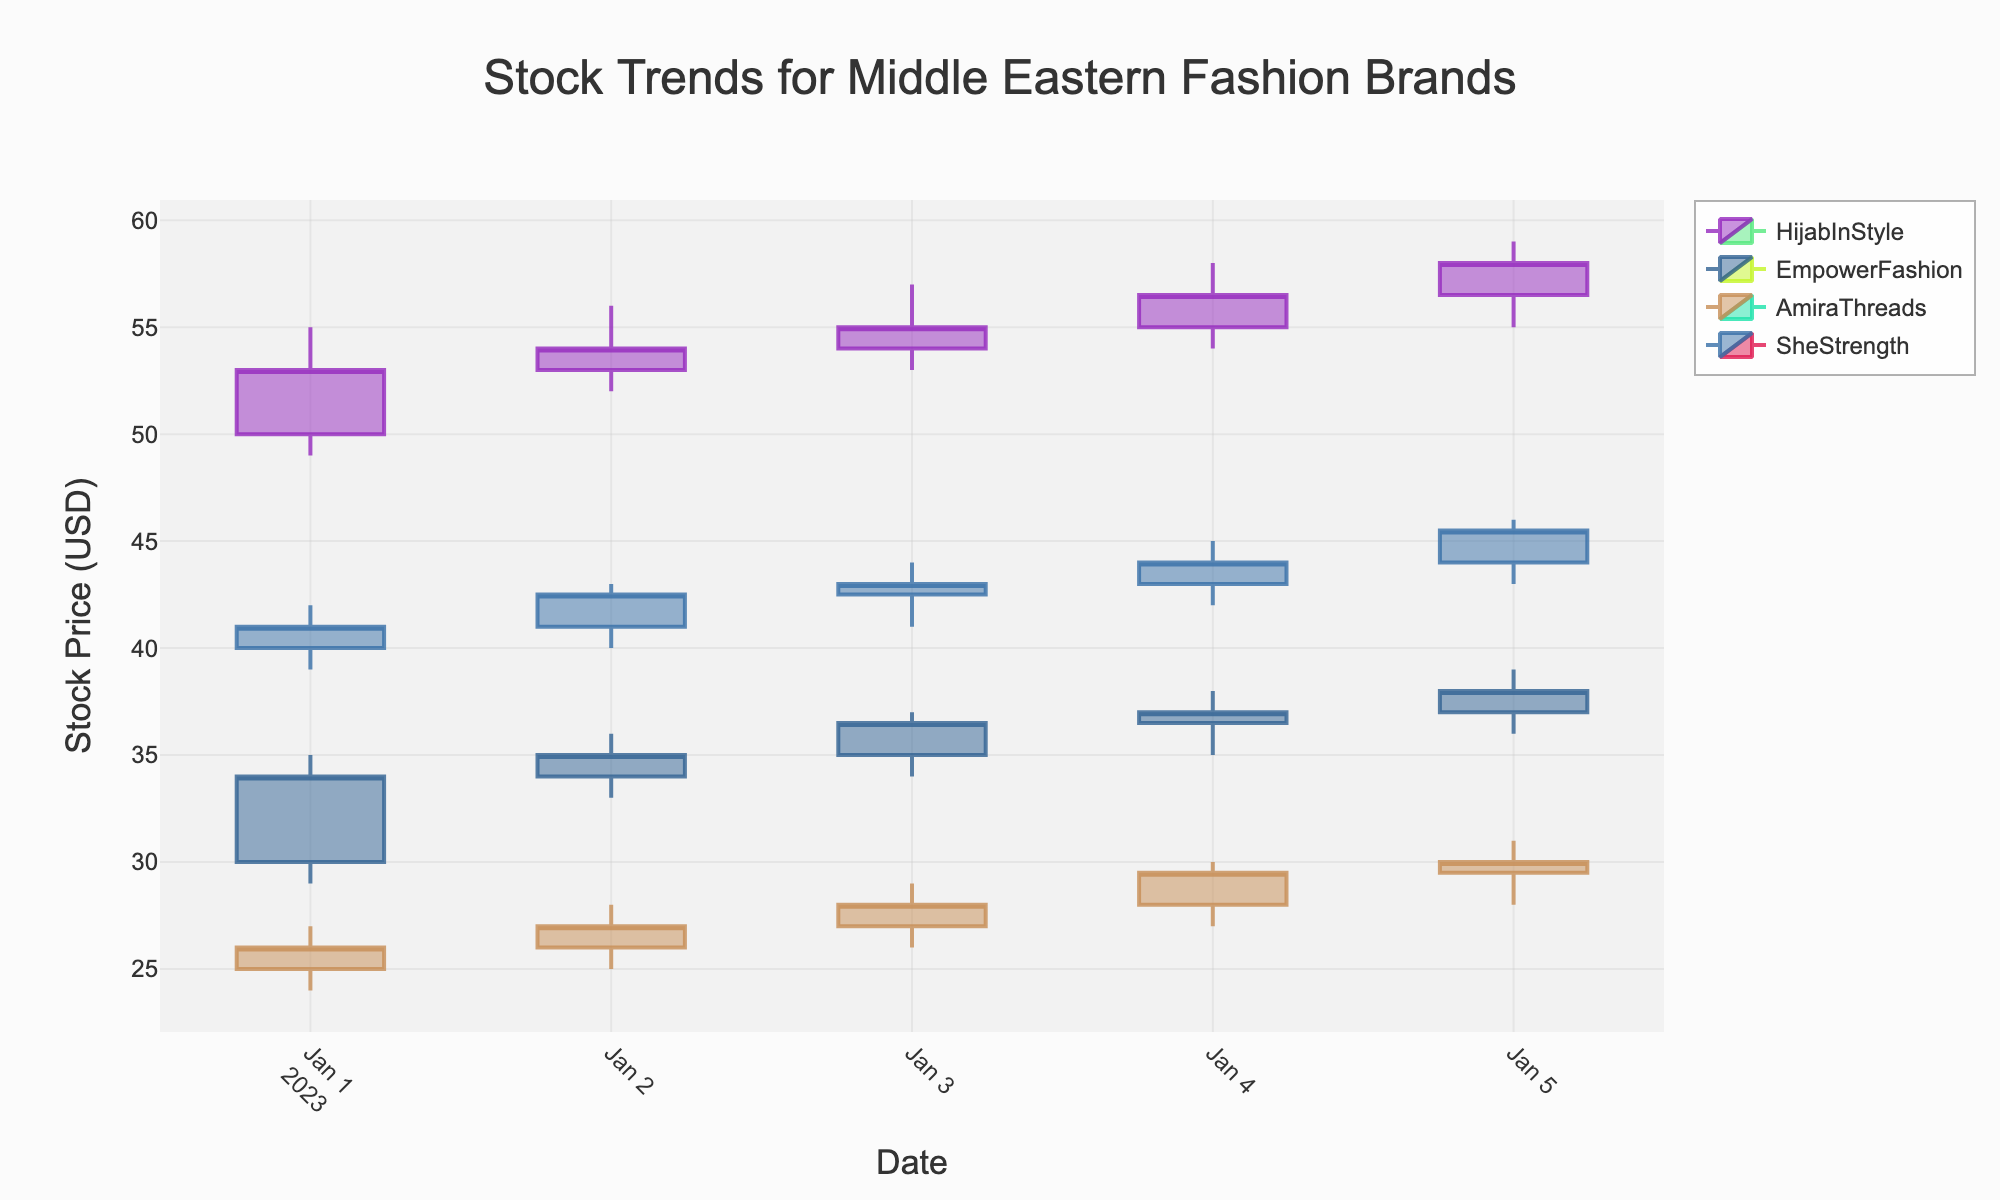Which brand has the highest closing price on January 5th? By observing the closing prices on January 5th, we compare HijabInStyle (58.0), EmpowerFashion (38.0), AmiraThreads (30.0), and SheStrength (45.5). HijabInStyle has the highest closing price.
Answer: HijabInStyle What is the average opening price for EmpwerFashion from January 1st to January 5th? The opening prices for EmpowerFashion from January 1st to January 5th are 30.0, 34.0, 35.0, 36.5, 37.0. The sum of these prices is 30.0 + 34.0 + 35.0 + 36.5 + 37.0, which equals 172.5. Dividing by 5 trading days, the average is 34.5.
Answer: 34.5 Which brand exhibited the largest increase in stock price over the period? To determine the largest increase, we calculate the difference between the closing prices on January 5th and January 1st for each brand. HijabInStyle increased from 53.0 to 58.0 (+5.0), EmpowerFashion from 34.0 to 38.0 (+4.0), AmiraThreads from 26.0 to 30.0 (+4.0), and SheStrength from 41.0 to 45.5 (+4.5). HijabInStyle shows the largest increase.
Answer: HijabInStyle Between AmiraThreads and SheStrength, which brand had a larger volume traded on January 3rd? On January 3rd, the volume traded for AmiraThreads is 1200 and for SheStrength is 1500. Comparing these values, SheStrength had the larger volume traded.
Answer: SheStrength On which date did HijabInStyle experience the highest single-day price increase in terms of closing price? Checking the daily differences in closing prices for HijabInStyle, we find: Jan 2: +1.0, Jan 3: +1.0, Jan 4: +1.5, Jan 5: +1.5. The highest single-day increase of +1.5 happened on January 4th and January 5th.
Answer: January 4th and 5th What is the total volume traded for HijabInStyle from January 1st to January 5th? The total volume is the sum of daily volumes for HijabInStyle from January 1st to January 5th: 1500 + 1600 + 1700 + 1800 + 1900 = 8500.
Answer: 8500 How does the closing price of EmpowerFashion on January 3rd compare to the opening price on the same day? The opening price for EmpowerFashion on January 3rd is 35.0 and the closing price is 36.5. Hence, the closing price is higher by 1.5.
Answer: Higher by 1.5 Which brand's stock price was the most stable, considering the smallest range (difference between high and low prices) over the period? To find stability, calculate the range (high - low) for each day, then average them for the period. HijabInStyle: avg(6)+avg(4)=Avg(5), EmpowerFashion=Avg(4.5), AmiraThreads=Avg(4), SheStrength=Avg(3.5)= SheStrength has the smallest ranges.
Answer: SheStrength 